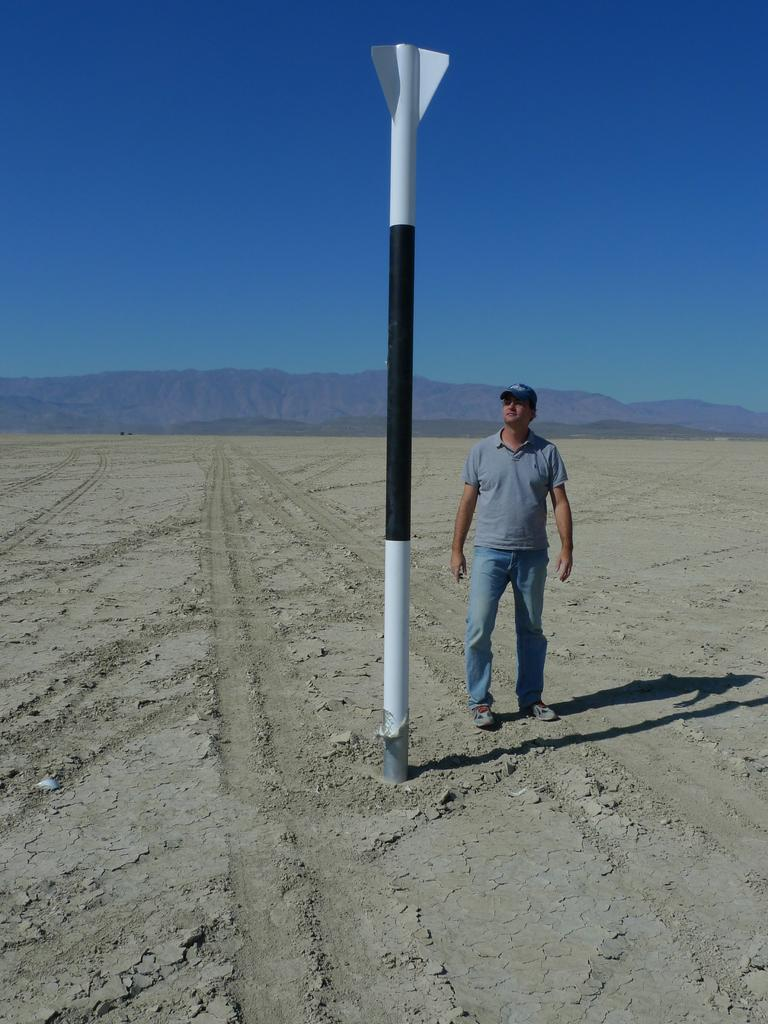What is the main subject in the foreground of the image? There is a man standing in the foreground of the image. What is the man standing on? The man is standing on land. What object is in front of the man? There is a pole in front of the man. What can be seen in the distance in the image? There are mountains visible in the background of the image, and the sky is also visible. What type of waste is scattered around the man in the image? There is no waste present in the image; it is a man standing on land with a pole in front of him. Can you see any insects flying around the man in the image? There is no mention of insects in the image; it only features a man, a pole, land, mountains, and the sky. 